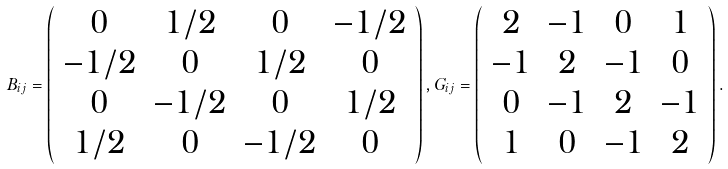Convert formula to latex. <formula><loc_0><loc_0><loc_500><loc_500>B _ { i j } = \left ( \begin{array} { c c c c } 0 & 1 / 2 & 0 & - 1 / 2 \\ - 1 / 2 & 0 & 1 / 2 & 0 \\ 0 & - 1 / 2 & 0 & 1 / 2 \\ 1 / 2 & 0 & - 1 / 2 & 0 \end{array} \right ) , G _ { i j } = \left ( \begin{array} { c c c c } 2 & - 1 & 0 & 1 \\ - 1 & 2 & - 1 & 0 \\ 0 & - 1 & 2 & - 1 \\ 1 & 0 & - 1 & 2 \end{array} \right ) .</formula> 